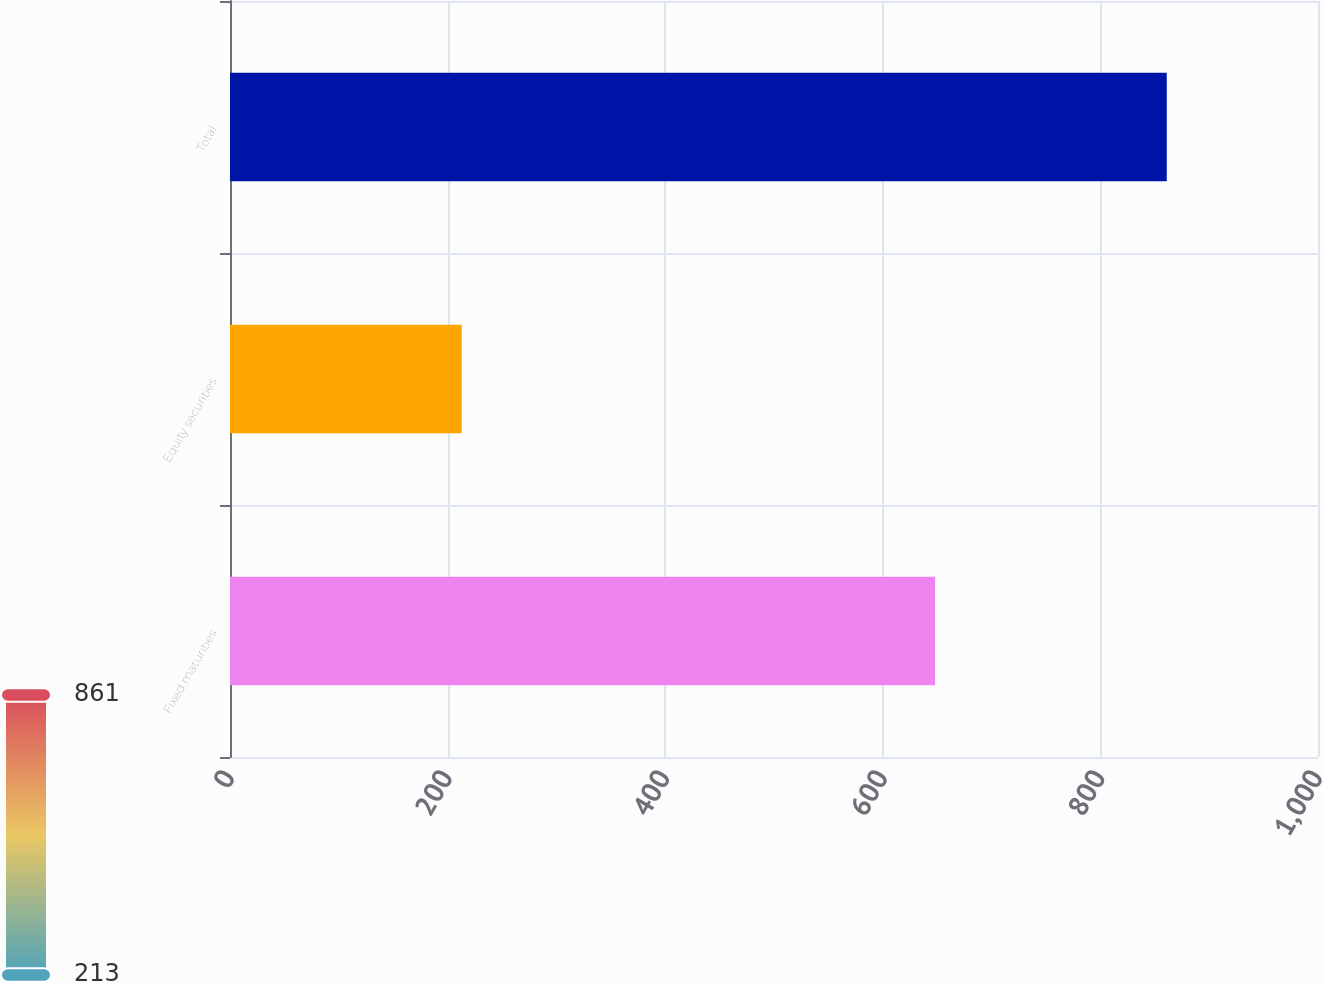<chart> <loc_0><loc_0><loc_500><loc_500><bar_chart><fcel>Fixed maturities<fcel>Equity securities<fcel>Total<nl><fcel>648<fcel>213<fcel>861<nl></chart> 